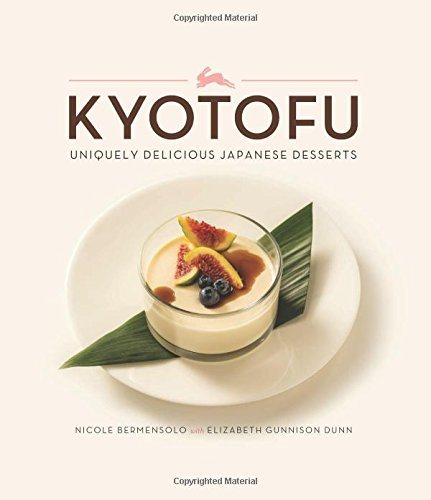What is the title of this book? The title of this delightful culinary book is 'Kyotofu: Uniquely Delicious Japanese Desserts', which explores a variety of innovative dessert recipes. 